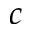<formula> <loc_0><loc_0><loc_500><loc_500>c</formula> 